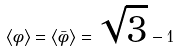<formula> <loc_0><loc_0><loc_500><loc_500>\left < \phi \right > = \left < \bar { \phi } \right > = \sqrt { 3 } - 1</formula> 